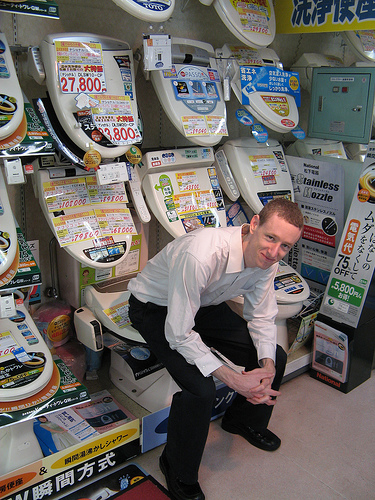What's the boy sitting on? The boy is creatively demonstrating a seated pose on one of the display toilets in what appears to be a store specializing in bathroom fixtures. 